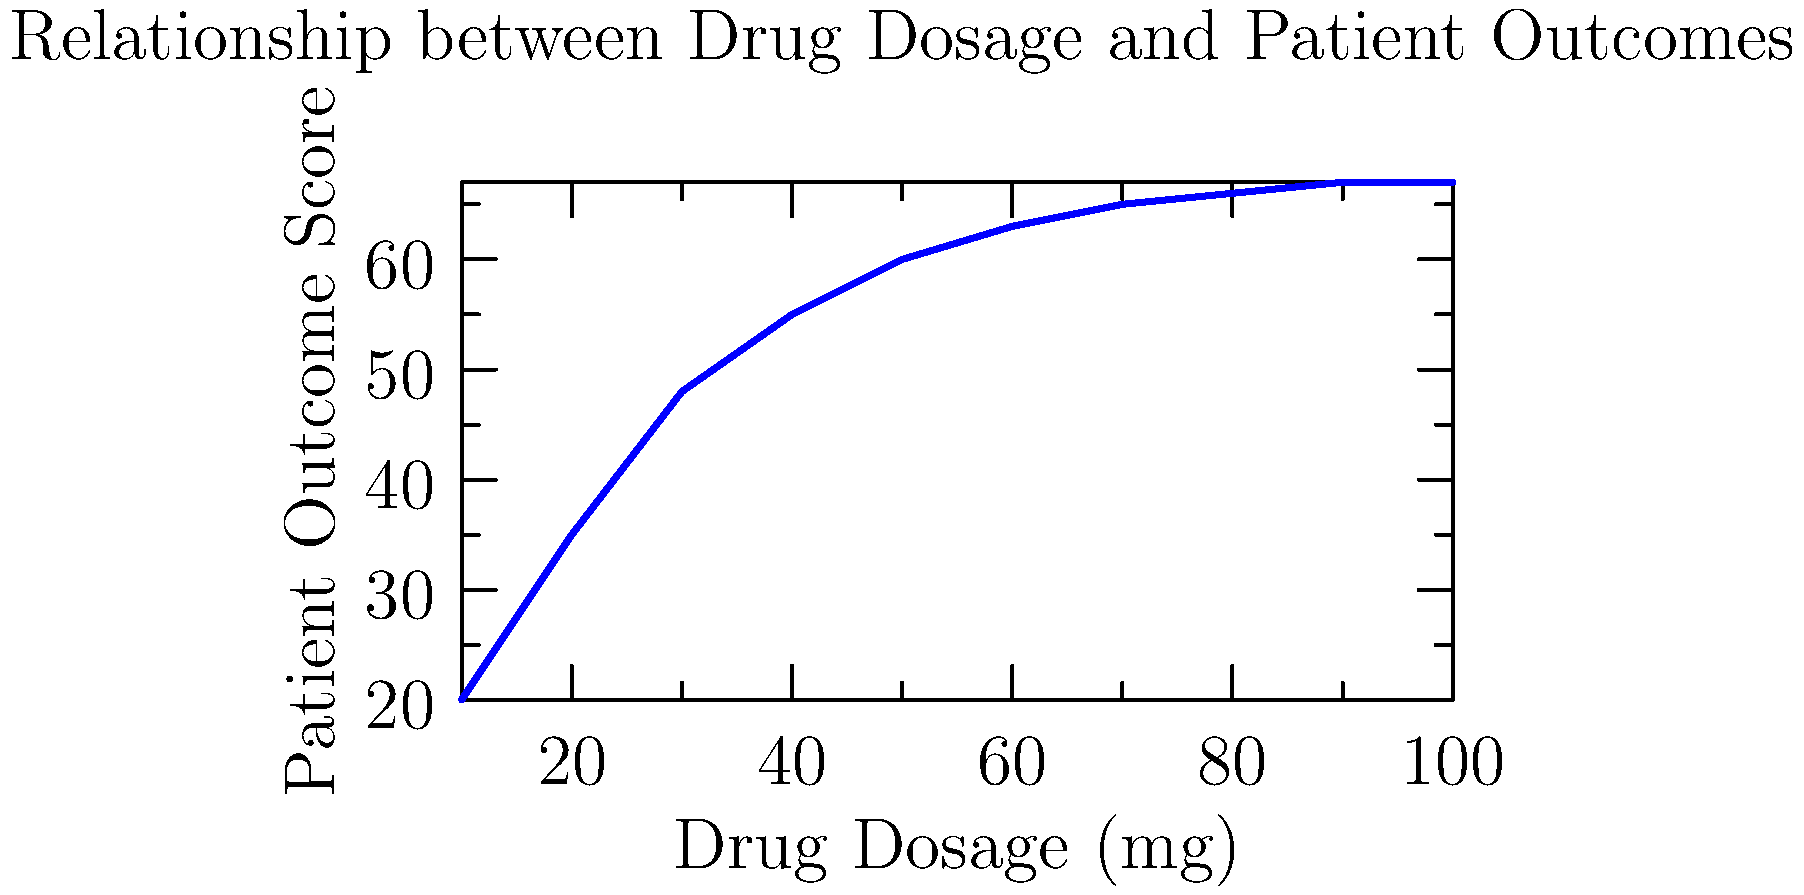Based on the scatter plot showing the relationship between drug dosage and patient outcomes, what type of relationship is observed, and what implications might this have for determining the optimal dosage range for this drug? To analyze this scatter plot:

1. Observe the overall trend: As drug dosage increases, patient outcome scores generally increase.

2. Note the shape of the curve: It's not a straight line, but shows a curved relationship.

3. Identify the pattern: The increase in patient outcomes is steeper at lower dosages and then levels off at higher dosages.

4. Recognize the relationship type: This is a non-linear relationship, specifically a logarithmic or diminishing returns curve.

5. Analyze the implications:
   a) There's a positive correlation between dosage and outcomes up to a point.
   b) The rate of improvement decreases as dosage increases.
   c) After about 70-80 mg, there's minimal additional benefit from increasing the dose.

6. Consider regulatory implications:
   a) The optimal dosage range likely falls where the curve begins to level off (around 60-70 mg).
   b) Doses beyond this point may not provide significant additional benefits but could increase the risk of side effects.
   c) A risk-benefit analysis would be crucial for doses in the higher range.

7. Potential next steps:
   a) Conduct further studies to precisely determine the point of diminishing returns.
   b) Investigate potential side effects at various dosage levels.
   c) Consider recommending a dosage range that balances efficacy with safety.
Answer: Non-linear relationship with diminishing returns; optimal dosage likely 60-70 mg where curve levels off, balancing efficacy and safety. 